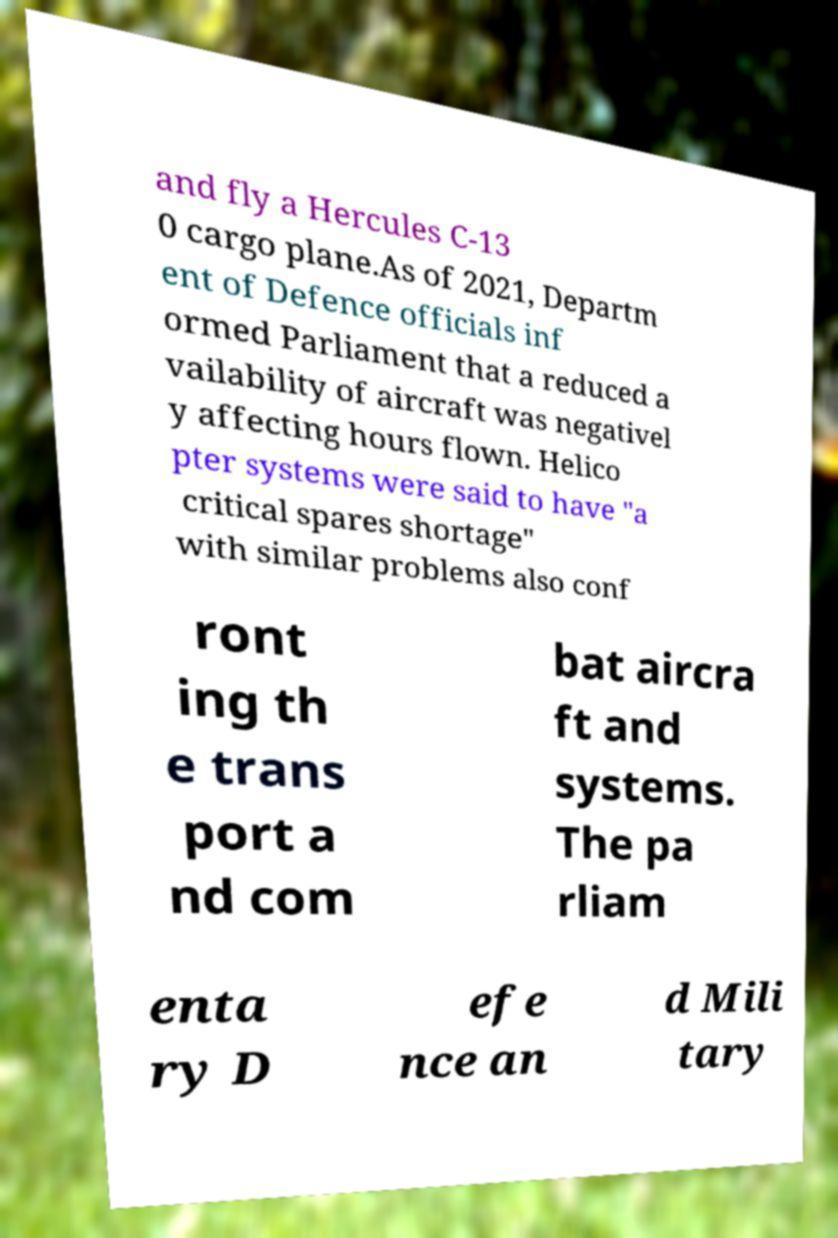Please read and relay the text visible in this image. What does it say? and fly a Hercules C-13 0 cargo plane.As of 2021, Departm ent of Defence officials inf ormed Parliament that a reduced a vailability of aircraft was negativel y affecting hours flown. Helico pter systems were said to have "a critical spares shortage" with similar problems also conf ront ing th e trans port a nd com bat aircra ft and systems. The pa rliam enta ry D efe nce an d Mili tary 